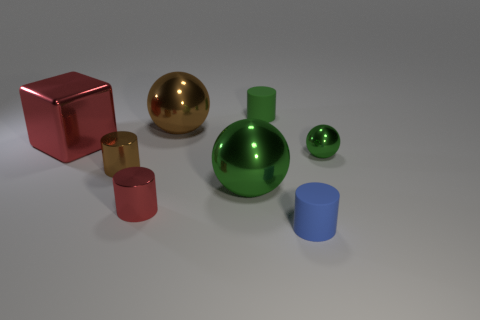Subtract all brown cylinders. How many cylinders are left? 3 Subtract all gray blocks. How many green balls are left? 2 Add 2 large green things. How many objects exist? 10 Subtract all brown spheres. How many spheres are left? 2 Subtract all cubes. How many objects are left? 7 Subtract 1 spheres. How many spheres are left? 2 Subtract all gray cylinders. Subtract all yellow cubes. How many cylinders are left? 4 Subtract all tiny green matte cylinders. Subtract all red metallic cubes. How many objects are left? 6 Add 3 small green shiny things. How many small green shiny things are left? 4 Add 2 tiny green metallic objects. How many tiny green metallic objects exist? 3 